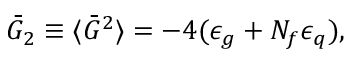Convert formula to latex. <formula><loc_0><loc_0><loc_500><loc_500>\bar { G } _ { 2 } \equiv \langle \bar { G } ^ { 2 } \rangle = - 4 ( \epsilon _ { g } + N _ { f } \epsilon _ { q } ) ,</formula> 